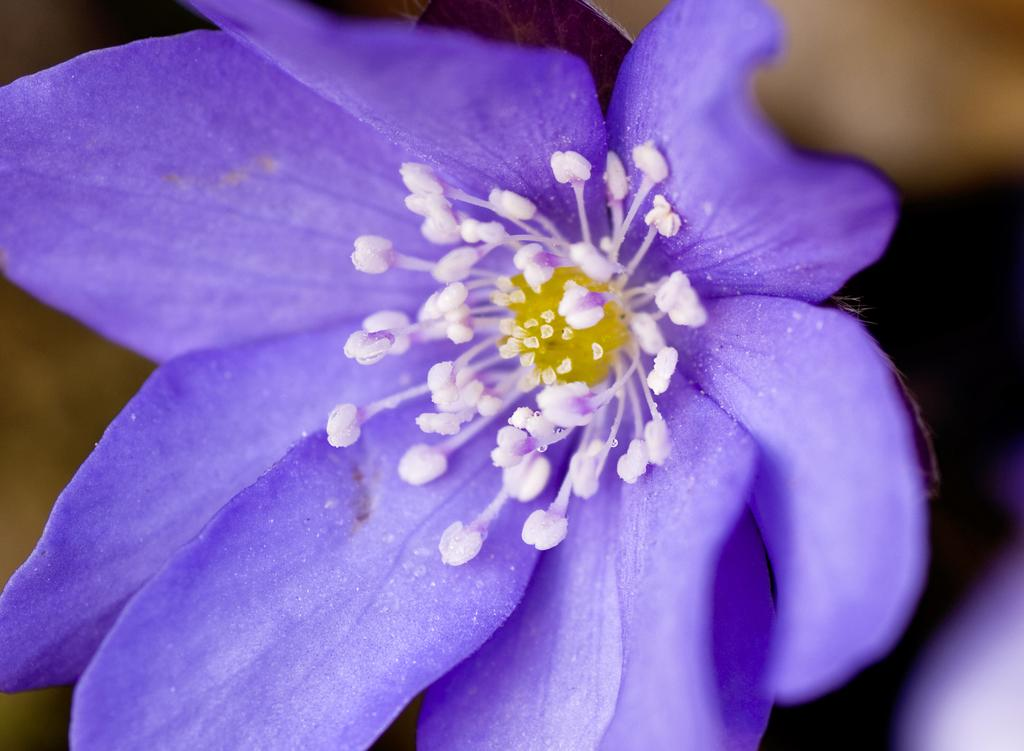What type of flower is present in the image? There is a purple color flower in the image. Can you describe the background of the image? The background of the image is blurred. How many bananas are sitting on the chair in the image? There are no bananas or chairs present in the image. What type of beast can be seen lurking in the background of the image? There is no beast present in the image; the background is blurred. 